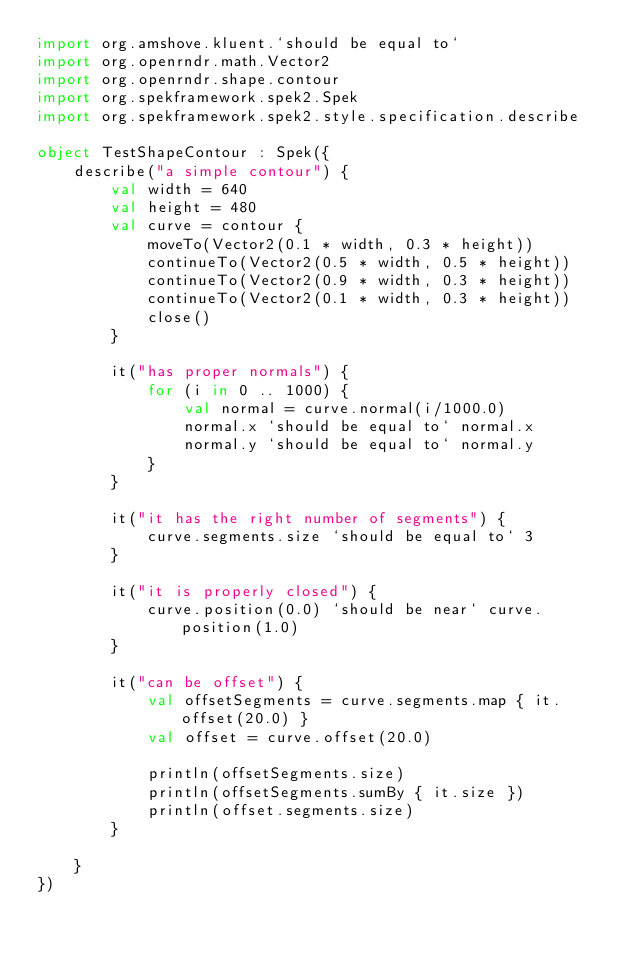<code> <loc_0><loc_0><loc_500><loc_500><_Kotlin_>import org.amshove.kluent.`should be equal to`
import org.openrndr.math.Vector2
import org.openrndr.shape.contour
import org.spekframework.spek2.Spek
import org.spekframework.spek2.style.specification.describe

object TestShapeContour : Spek({
    describe("a simple contour") {
        val width = 640
        val height = 480
        val curve = contour {
            moveTo(Vector2(0.1 * width, 0.3 * height))
            continueTo(Vector2(0.5 * width, 0.5 * height))
            continueTo(Vector2(0.9 * width, 0.3 * height))
            continueTo(Vector2(0.1 * width, 0.3 * height))
            close()
        }

        it("has proper normals") {
            for (i in 0 .. 1000) {
                val normal = curve.normal(i/1000.0)
                normal.x `should be equal to` normal.x
                normal.y `should be equal to` normal.y
            }
        }

        it("it has the right number of segments") {
            curve.segments.size `should be equal to` 3
        }

        it("it is properly closed") {
            curve.position(0.0) `should be near` curve.position(1.0)
        }

        it("can be offset") {
            val offsetSegments = curve.segments.map { it.offset(20.0) }
            val offset = curve.offset(20.0)

            println(offsetSegments.size)
            println(offsetSegments.sumBy { it.size })
            println(offset.segments.size)
        }

    }
})
</code> 